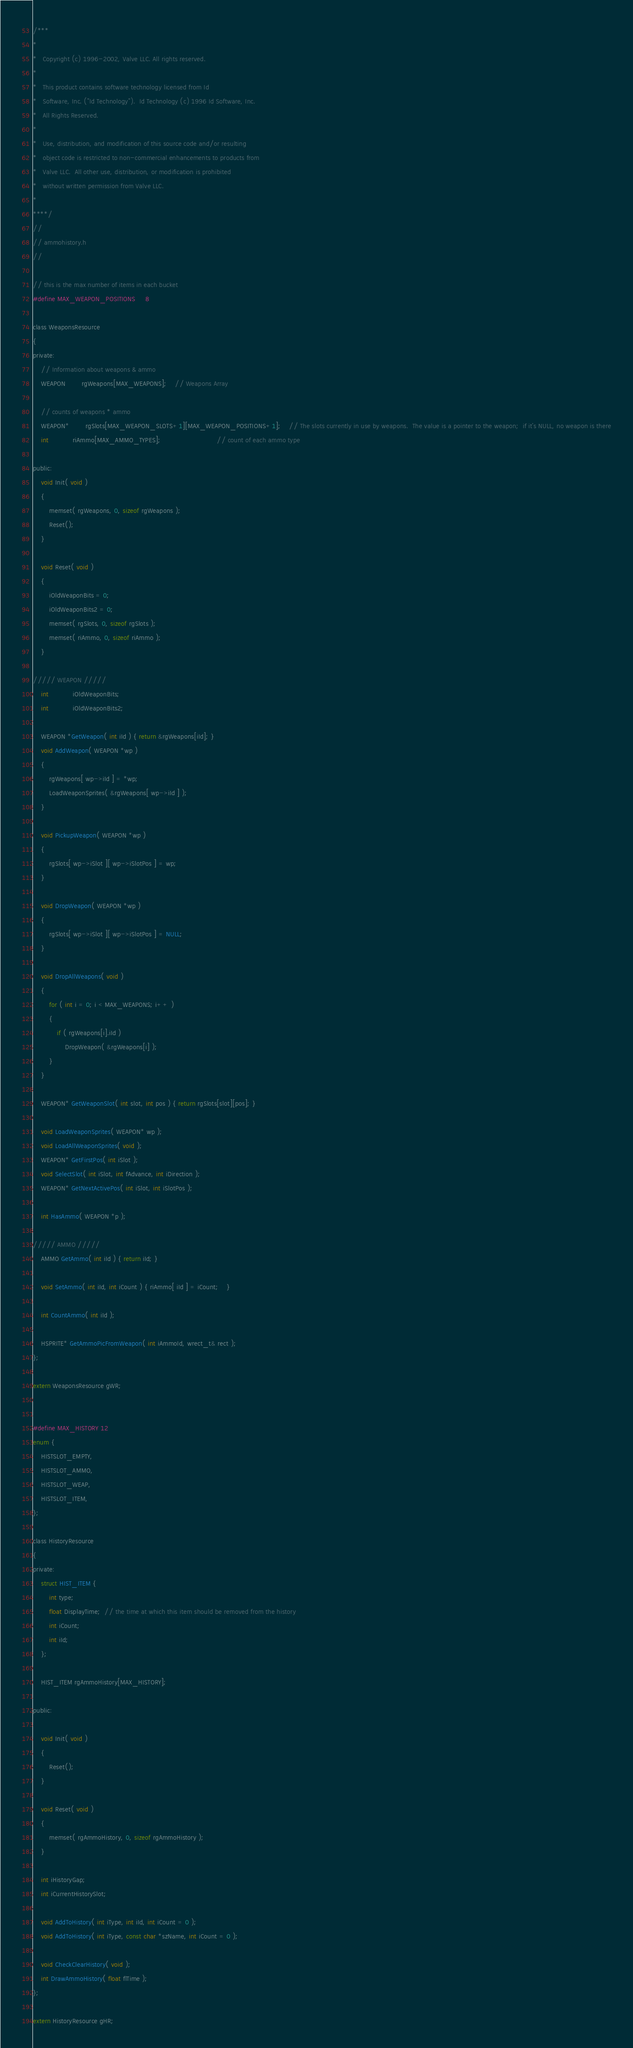<code> <loc_0><loc_0><loc_500><loc_500><_C_>/***
*
*	Copyright (c) 1996-2002, Valve LLC. All rights reserved.
*	
*	This product contains software technology licensed from Id 
*	Software, Inc. ("Id Technology").  Id Technology (c) 1996 Id Software, Inc. 
*	All Rights Reserved.
*
*   Use, distribution, and modification of this source code and/or resulting
*   object code is restricted to non-commercial enhancements to products from
*   Valve LLC.  All other use, distribution, or modification is prohibited
*   without written permission from Valve LLC.
*
****/
//
// ammohistory.h
//

// this is the max number of items in each bucket
#define MAX_WEAPON_POSITIONS		8

class WeaponsResource
{
private:
	// Information about weapons & ammo
	WEAPON		rgWeapons[MAX_WEAPONS];	// Weapons Array

	// counts of weapons * ammo
	WEAPON*		rgSlots[MAX_WEAPON_SLOTS+1][MAX_WEAPON_POSITIONS+1];	// The slots currently in use by weapons.  The value is a pointer to the weapon;  if it's NULL, no weapon is there
	int			riAmmo[MAX_AMMO_TYPES];							// count of each ammo type

public:
	void Init( void )
	{
		memset( rgWeapons, 0, sizeof rgWeapons );
		Reset();
	}

	void Reset( void )
	{
		iOldWeaponBits = 0;
		iOldWeaponBits2 = 0;
		memset( rgSlots, 0, sizeof rgSlots );
		memset( riAmmo, 0, sizeof riAmmo );
	}

///// WEAPON /////
	int			iOldWeaponBits;
	int			iOldWeaponBits2;

	WEAPON *GetWeapon( int iId ) { return &rgWeapons[iId]; }
	void AddWeapon( WEAPON *wp ) 
	{ 
		rgWeapons[ wp->iId ] = *wp;	
		LoadWeaponSprites( &rgWeapons[ wp->iId ] );
	}

	void PickupWeapon( WEAPON *wp )
	{
		rgSlots[ wp->iSlot ][ wp->iSlotPos ] = wp;
	}

	void DropWeapon( WEAPON *wp )
	{
		rgSlots[ wp->iSlot ][ wp->iSlotPos ] = NULL;
	}

	void DropAllWeapons( void )
	{
		for ( int i = 0; i < MAX_WEAPONS; i++ )
		{
			if ( rgWeapons[i].iId )
				DropWeapon( &rgWeapons[i] );
		}
	}

	WEAPON* GetWeaponSlot( int slot, int pos ) { return rgSlots[slot][pos]; }

	void LoadWeaponSprites( WEAPON* wp );
	void LoadAllWeaponSprites( void );
	WEAPON* GetFirstPos( int iSlot );
	void SelectSlot( int iSlot, int fAdvance, int iDirection );
	WEAPON* GetNextActivePos( int iSlot, int iSlotPos );

	int HasAmmo( WEAPON *p );

///// AMMO /////
	AMMO GetAmmo( int iId ) { return iId; }

	void SetAmmo( int iId, int iCount ) { riAmmo[ iId ] = iCount;	}

	int CountAmmo( int iId );

	HSPRITE* GetAmmoPicFromWeapon( int iAmmoId, wrect_t& rect );
};

extern WeaponsResource gWR;


#define MAX_HISTORY 12
enum {
	HISTSLOT_EMPTY,
	HISTSLOT_AMMO,
	HISTSLOT_WEAP,
	HISTSLOT_ITEM,
};

class HistoryResource
{
private:
	struct HIST_ITEM {
		int type;
		float DisplayTime;  // the time at which this item should be removed from the history
		int iCount;
		int iId;
	};

	HIST_ITEM rgAmmoHistory[MAX_HISTORY];

public:

	void Init( void )
	{
		Reset();
	}

	void Reset( void )
	{
		memset( rgAmmoHistory, 0, sizeof rgAmmoHistory );
	}

	int iHistoryGap;
	int iCurrentHistorySlot;

	void AddToHistory( int iType, int iId, int iCount = 0 );
	void AddToHistory( int iType, const char *szName, int iCount = 0 );

	void CheckClearHistory( void );
	int DrawAmmoHistory( float flTime );
};

extern HistoryResource gHR;



</code> 